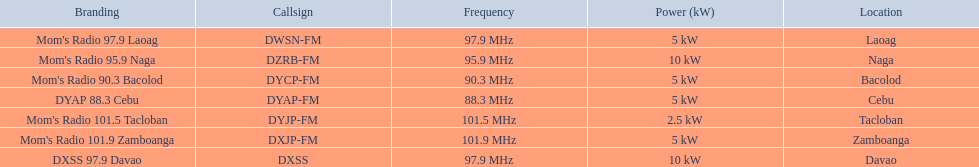Can you list the stations that require less than 10kw of power? Mom's Radio 97.9 Laoag, Mom's Radio 90.3 Bacolod, DYAP 88.3 Cebu, Mom's Radio 101.5 Tacloban, Mom's Radio 101.9 Zamboanga. Also, are there any stations that need less than 5kw of power, and if there are, which ones are they? Mom's Radio 101.5 Tacloban. 